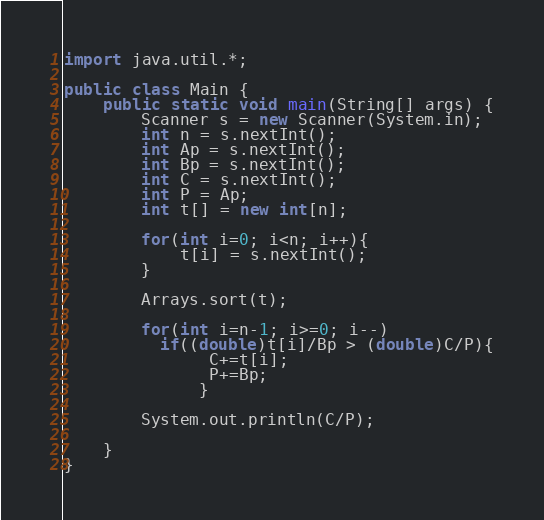Convert code to text. <code><loc_0><loc_0><loc_500><loc_500><_Java_>import java.util.*;

public class Main {
	public static void main(String[] args) {
		Scanner s = new Scanner(System.in);
		int n = s.nextInt();
		int Ap = s.nextInt();
		int Bp = s.nextInt();
		int C = s.nextInt();
		int P = Ap;
		int t[] = new int[n];
		
		for(int i=0; i<n; i++){
			t[i] = s.nextInt();
		}
		
		Arrays.sort(t);
		
		for(int i=n-1; i>=0; i--)
		  if((double)t[i]/Bp > (double)C/P){
			   C+=t[i];
			   P+=Bp;
			  }

		System.out.println(C/P);

	}
}</code> 